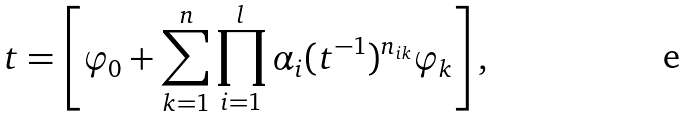<formula> <loc_0><loc_0><loc_500><loc_500>t = \left [ \varphi _ { 0 } + \sum _ { k = 1 } ^ { n } \prod _ { i = 1 } ^ { l } \alpha _ { i } ( t ^ { - 1 } ) ^ { n _ { i k } } \varphi _ { k } \right ] ,</formula> 